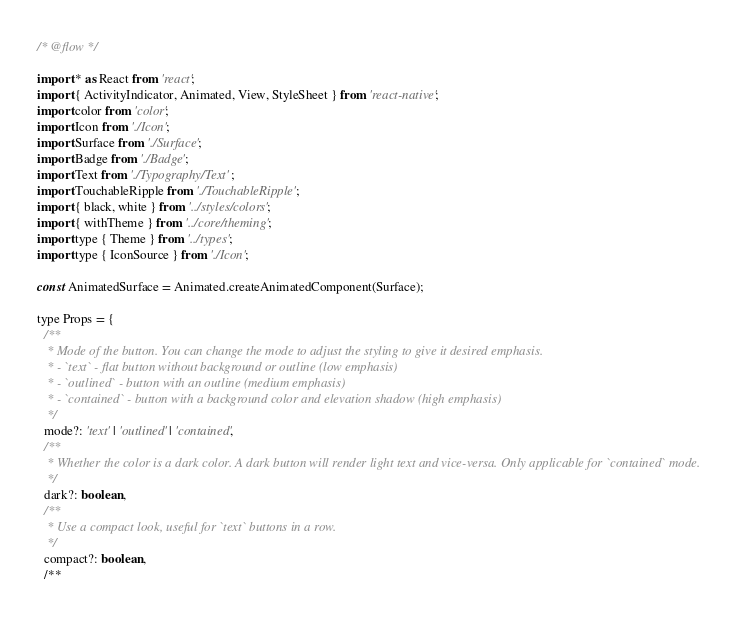<code> <loc_0><loc_0><loc_500><loc_500><_JavaScript_>/* @flow */

import * as React from 'react';
import { ActivityIndicator, Animated, View, StyleSheet } from 'react-native';
import color from 'color';
import Icon from './Icon';
import Surface from './Surface';
import Badge from './Badge';
import Text from './Typography/Text';
import TouchableRipple from './TouchableRipple';
import { black, white } from '../styles/colors';
import { withTheme } from '../core/theming';
import type { Theme } from '../types';
import type { IconSource } from './Icon';

const AnimatedSurface = Animated.createAnimatedComponent(Surface);

type Props = {
  /**
   * Mode of the button. You can change the mode to adjust the styling to give it desired emphasis.
   * - `text` - flat button without background or outline (low emphasis)
   * - `outlined` - button with an outline (medium emphasis)
   * - `contained` - button with a background color and elevation shadow (high emphasis)
   */
  mode?: 'text' | 'outlined' | 'contained',
  /**
   * Whether the color is a dark color. A dark button will render light text and vice-versa. Only applicable for `contained` mode.
   */
  dark?: boolean,
  /**
   * Use a compact look, useful for `text` buttons in a row.
   */
  compact?: boolean,
  /**</code> 